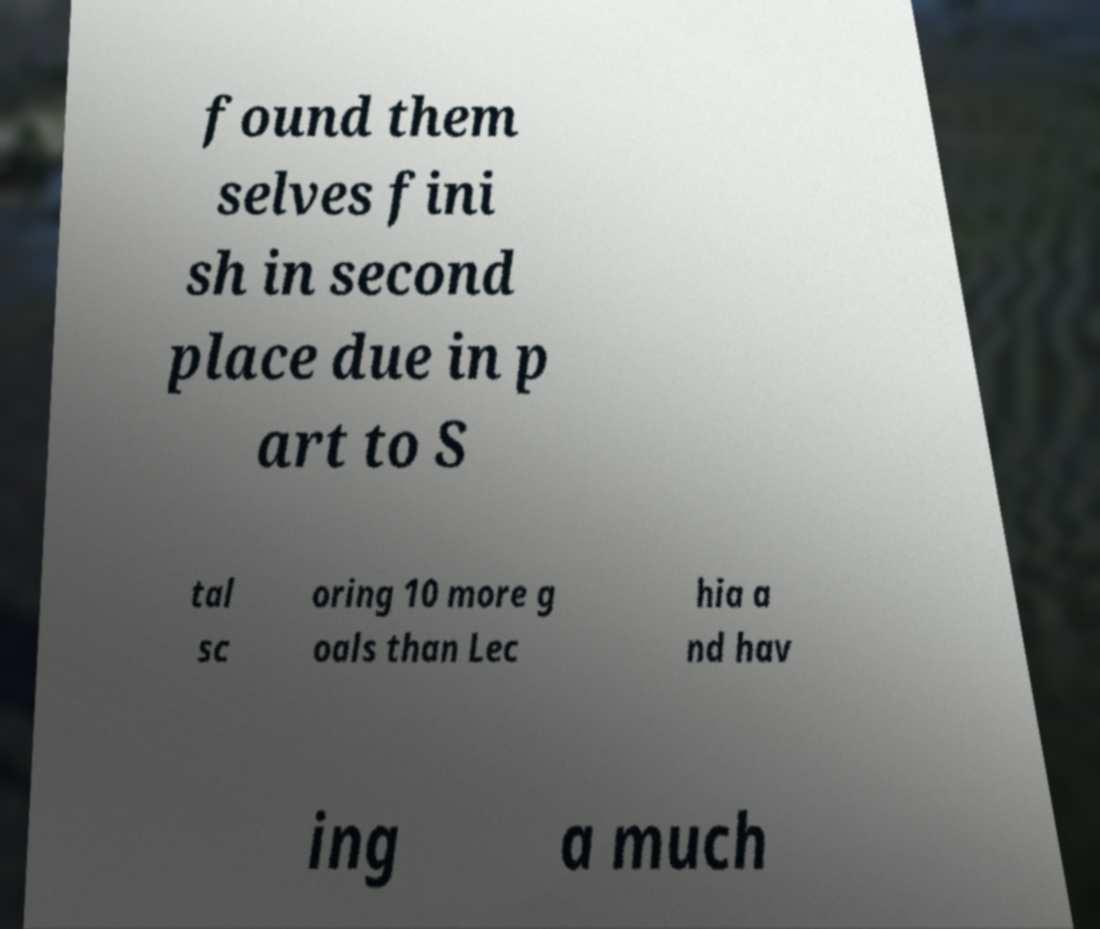I need the written content from this picture converted into text. Can you do that? found them selves fini sh in second place due in p art to S tal sc oring 10 more g oals than Lec hia a nd hav ing a much 